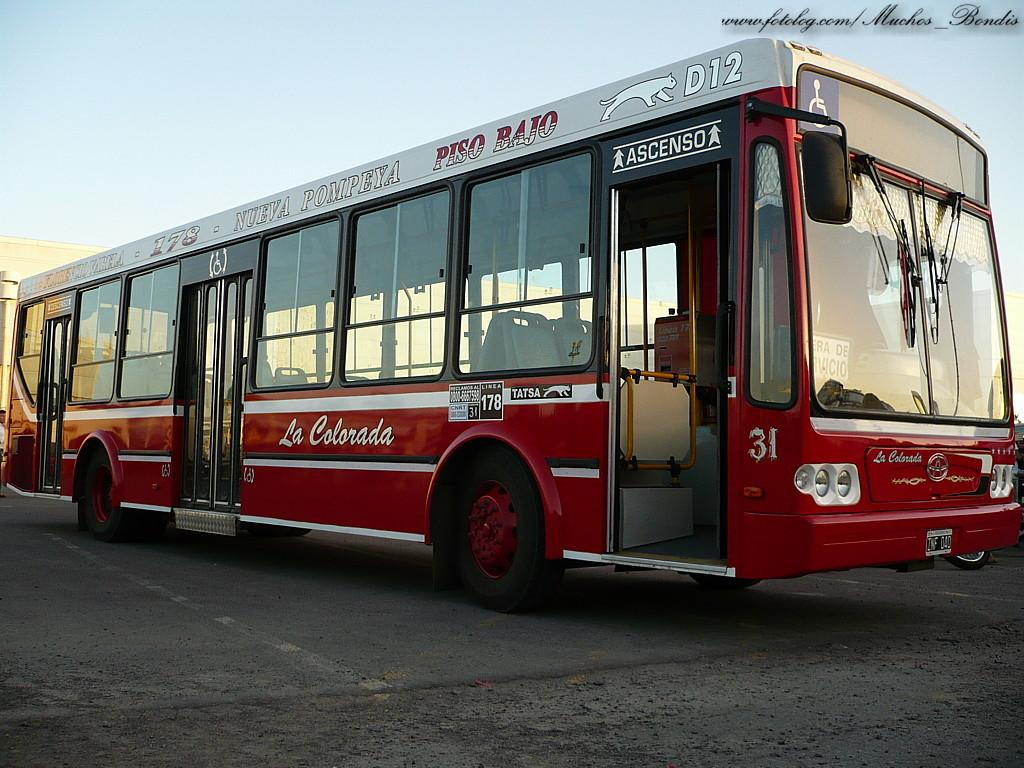What is the main subject of the image? There is a bus in the image. Where is the bus located? The bus is on a road. How is the bus positioned in the image? The bus is in the center of the image. Can you see any giants walking near the bus in the image? There are no giants present in the image; it only features a bus on a road. 